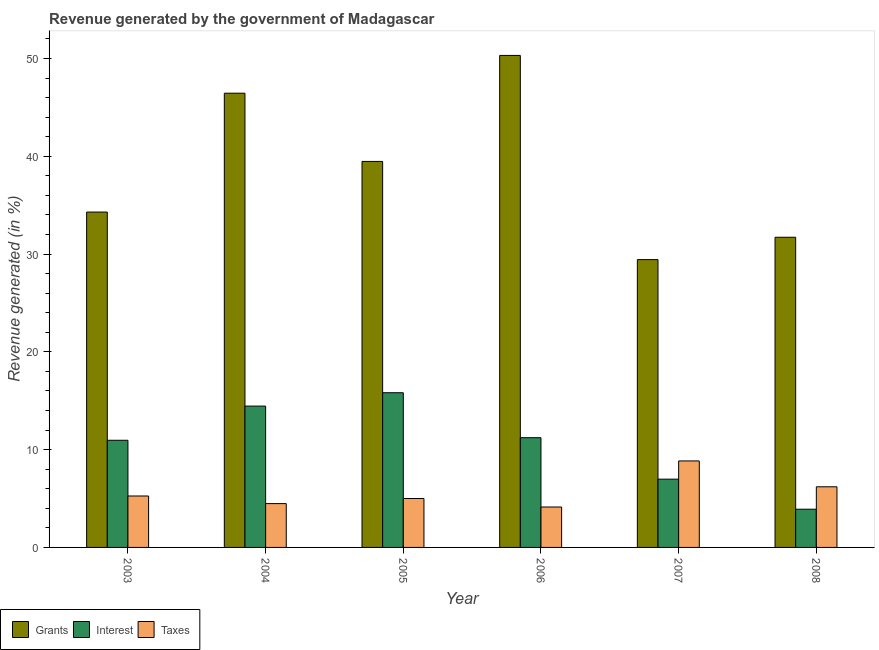How many different coloured bars are there?
Ensure brevity in your answer.  3. Are the number of bars per tick equal to the number of legend labels?
Keep it short and to the point. Yes. What is the percentage of revenue generated by taxes in 2007?
Offer a very short reply. 8.85. Across all years, what is the maximum percentage of revenue generated by grants?
Offer a terse response. 50.32. Across all years, what is the minimum percentage of revenue generated by taxes?
Your response must be concise. 4.13. In which year was the percentage of revenue generated by interest minimum?
Offer a very short reply. 2008. What is the total percentage of revenue generated by taxes in the graph?
Ensure brevity in your answer.  33.93. What is the difference between the percentage of revenue generated by taxes in 2005 and that in 2007?
Provide a short and direct response. -3.84. What is the difference between the percentage of revenue generated by grants in 2006 and the percentage of revenue generated by taxes in 2008?
Ensure brevity in your answer.  18.6. What is the average percentage of revenue generated by grants per year?
Make the answer very short. 38.62. In how many years, is the percentage of revenue generated by interest greater than 12 %?
Provide a succinct answer. 2. What is the ratio of the percentage of revenue generated by interest in 2004 to that in 2008?
Your answer should be very brief. 3.7. Is the percentage of revenue generated by interest in 2004 less than that in 2006?
Provide a short and direct response. No. Is the difference between the percentage of revenue generated by taxes in 2005 and 2007 greater than the difference between the percentage of revenue generated by grants in 2005 and 2007?
Provide a succinct answer. No. What is the difference between the highest and the second highest percentage of revenue generated by taxes?
Keep it short and to the point. 2.65. What is the difference between the highest and the lowest percentage of revenue generated by grants?
Offer a very short reply. 20.88. In how many years, is the percentage of revenue generated by grants greater than the average percentage of revenue generated by grants taken over all years?
Your answer should be compact. 3. Is the sum of the percentage of revenue generated by grants in 2003 and 2006 greater than the maximum percentage of revenue generated by taxes across all years?
Offer a terse response. Yes. What does the 2nd bar from the left in 2005 represents?
Offer a very short reply. Interest. What does the 1st bar from the right in 2008 represents?
Your answer should be very brief. Taxes. Are the values on the major ticks of Y-axis written in scientific E-notation?
Your answer should be very brief. No. Does the graph contain any zero values?
Keep it short and to the point. No. How many legend labels are there?
Provide a succinct answer. 3. What is the title of the graph?
Your response must be concise. Revenue generated by the government of Madagascar. What is the label or title of the X-axis?
Keep it short and to the point. Year. What is the label or title of the Y-axis?
Provide a succinct answer. Revenue generated (in %). What is the Revenue generated (in %) of Grants in 2003?
Give a very brief answer. 34.3. What is the Revenue generated (in %) of Interest in 2003?
Your response must be concise. 10.96. What is the Revenue generated (in %) in Taxes in 2003?
Keep it short and to the point. 5.26. What is the Revenue generated (in %) in Grants in 2004?
Your response must be concise. 46.45. What is the Revenue generated (in %) of Interest in 2004?
Offer a terse response. 14.45. What is the Revenue generated (in %) in Taxes in 2004?
Ensure brevity in your answer.  4.48. What is the Revenue generated (in %) in Grants in 2005?
Provide a succinct answer. 39.48. What is the Revenue generated (in %) in Interest in 2005?
Your response must be concise. 15.82. What is the Revenue generated (in %) in Taxes in 2005?
Make the answer very short. 5. What is the Revenue generated (in %) of Grants in 2006?
Your response must be concise. 50.32. What is the Revenue generated (in %) in Interest in 2006?
Your response must be concise. 11.22. What is the Revenue generated (in %) of Taxes in 2006?
Make the answer very short. 4.13. What is the Revenue generated (in %) in Grants in 2007?
Offer a terse response. 29.44. What is the Revenue generated (in %) in Interest in 2007?
Keep it short and to the point. 6.98. What is the Revenue generated (in %) of Taxes in 2007?
Provide a short and direct response. 8.85. What is the Revenue generated (in %) of Grants in 2008?
Your answer should be compact. 31.72. What is the Revenue generated (in %) in Interest in 2008?
Your response must be concise. 3.91. What is the Revenue generated (in %) of Taxes in 2008?
Offer a very short reply. 6.2. Across all years, what is the maximum Revenue generated (in %) in Grants?
Keep it short and to the point. 50.32. Across all years, what is the maximum Revenue generated (in %) in Interest?
Your response must be concise. 15.82. Across all years, what is the maximum Revenue generated (in %) of Taxes?
Your response must be concise. 8.85. Across all years, what is the minimum Revenue generated (in %) in Grants?
Offer a terse response. 29.44. Across all years, what is the minimum Revenue generated (in %) in Interest?
Make the answer very short. 3.91. Across all years, what is the minimum Revenue generated (in %) in Taxes?
Your response must be concise. 4.13. What is the total Revenue generated (in %) of Grants in the graph?
Offer a terse response. 231.7. What is the total Revenue generated (in %) in Interest in the graph?
Make the answer very short. 63.35. What is the total Revenue generated (in %) of Taxes in the graph?
Your response must be concise. 33.93. What is the difference between the Revenue generated (in %) of Grants in 2003 and that in 2004?
Your response must be concise. -12.16. What is the difference between the Revenue generated (in %) in Interest in 2003 and that in 2004?
Ensure brevity in your answer.  -3.5. What is the difference between the Revenue generated (in %) of Taxes in 2003 and that in 2004?
Give a very brief answer. 0.78. What is the difference between the Revenue generated (in %) of Grants in 2003 and that in 2005?
Your answer should be very brief. -5.18. What is the difference between the Revenue generated (in %) in Interest in 2003 and that in 2005?
Your answer should be very brief. -4.86. What is the difference between the Revenue generated (in %) in Taxes in 2003 and that in 2005?
Give a very brief answer. 0.26. What is the difference between the Revenue generated (in %) in Grants in 2003 and that in 2006?
Offer a very short reply. -16.02. What is the difference between the Revenue generated (in %) in Interest in 2003 and that in 2006?
Give a very brief answer. -0.26. What is the difference between the Revenue generated (in %) of Taxes in 2003 and that in 2006?
Your answer should be very brief. 1.13. What is the difference between the Revenue generated (in %) in Grants in 2003 and that in 2007?
Provide a succinct answer. 4.86. What is the difference between the Revenue generated (in %) in Interest in 2003 and that in 2007?
Keep it short and to the point. 3.98. What is the difference between the Revenue generated (in %) of Taxes in 2003 and that in 2007?
Ensure brevity in your answer.  -3.59. What is the difference between the Revenue generated (in %) of Grants in 2003 and that in 2008?
Ensure brevity in your answer.  2.58. What is the difference between the Revenue generated (in %) of Interest in 2003 and that in 2008?
Keep it short and to the point. 7.05. What is the difference between the Revenue generated (in %) in Taxes in 2003 and that in 2008?
Keep it short and to the point. -0.94. What is the difference between the Revenue generated (in %) in Grants in 2004 and that in 2005?
Keep it short and to the point. 6.98. What is the difference between the Revenue generated (in %) in Interest in 2004 and that in 2005?
Your response must be concise. -1.37. What is the difference between the Revenue generated (in %) in Taxes in 2004 and that in 2005?
Offer a very short reply. -0.52. What is the difference between the Revenue generated (in %) in Grants in 2004 and that in 2006?
Ensure brevity in your answer.  -3.86. What is the difference between the Revenue generated (in %) of Interest in 2004 and that in 2006?
Your answer should be very brief. 3.23. What is the difference between the Revenue generated (in %) in Taxes in 2004 and that in 2006?
Offer a very short reply. 0.35. What is the difference between the Revenue generated (in %) of Grants in 2004 and that in 2007?
Provide a succinct answer. 17.02. What is the difference between the Revenue generated (in %) of Interest in 2004 and that in 2007?
Your answer should be very brief. 7.47. What is the difference between the Revenue generated (in %) of Taxes in 2004 and that in 2007?
Make the answer very short. -4.36. What is the difference between the Revenue generated (in %) in Grants in 2004 and that in 2008?
Your answer should be compact. 14.73. What is the difference between the Revenue generated (in %) of Interest in 2004 and that in 2008?
Provide a succinct answer. 10.55. What is the difference between the Revenue generated (in %) of Taxes in 2004 and that in 2008?
Your answer should be compact. -1.72. What is the difference between the Revenue generated (in %) in Grants in 2005 and that in 2006?
Your response must be concise. -10.84. What is the difference between the Revenue generated (in %) in Interest in 2005 and that in 2006?
Your answer should be compact. 4.6. What is the difference between the Revenue generated (in %) of Taxes in 2005 and that in 2006?
Keep it short and to the point. 0.87. What is the difference between the Revenue generated (in %) of Grants in 2005 and that in 2007?
Make the answer very short. 10.04. What is the difference between the Revenue generated (in %) in Interest in 2005 and that in 2007?
Provide a short and direct response. 8.84. What is the difference between the Revenue generated (in %) in Taxes in 2005 and that in 2007?
Provide a short and direct response. -3.84. What is the difference between the Revenue generated (in %) in Grants in 2005 and that in 2008?
Provide a short and direct response. 7.75. What is the difference between the Revenue generated (in %) in Interest in 2005 and that in 2008?
Make the answer very short. 11.91. What is the difference between the Revenue generated (in %) of Taxes in 2005 and that in 2008?
Your answer should be very brief. -1.2. What is the difference between the Revenue generated (in %) in Grants in 2006 and that in 2007?
Offer a terse response. 20.88. What is the difference between the Revenue generated (in %) of Interest in 2006 and that in 2007?
Your answer should be compact. 4.24. What is the difference between the Revenue generated (in %) in Taxes in 2006 and that in 2007?
Your answer should be compact. -4.71. What is the difference between the Revenue generated (in %) in Grants in 2006 and that in 2008?
Give a very brief answer. 18.6. What is the difference between the Revenue generated (in %) of Interest in 2006 and that in 2008?
Your response must be concise. 7.32. What is the difference between the Revenue generated (in %) of Taxes in 2006 and that in 2008?
Provide a succinct answer. -2.07. What is the difference between the Revenue generated (in %) of Grants in 2007 and that in 2008?
Provide a short and direct response. -2.29. What is the difference between the Revenue generated (in %) of Interest in 2007 and that in 2008?
Offer a very short reply. 3.07. What is the difference between the Revenue generated (in %) of Taxes in 2007 and that in 2008?
Your response must be concise. 2.65. What is the difference between the Revenue generated (in %) in Grants in 2003 and the Revenue generated (in %) in Interest in 2004?
Make the answer very short. 19.84. What is the difference between the Revenue generated (in %) of Grants in 2003 and the Revenue generated (in %) of Taxes in 2004?
Offer a very short reply. 29.82. What is the difference between the Revenue generated (in %) of Interest in 2003 and the Revenue generated (in %) of Taxes in 2004?
Make the answer very short. 6.48. What is the difference between the Revenue generated (in %) in Grants in 2003 and the Revenue generated (in %) in Interest in 2005?
Your answer should be very brief. 18.48. What is the difference between the Revenue generated (in %) in Grants in 2003 and the Revenue generated (in %) in Taxes in 2005?
Make the answer very short. 29.3. What is the difference between the Revenue generated (in %) of Interest in 2003 and the Revenue generated (in %) of Taxes in 2005?
Ensure brevity in your answer.  5.96. What is the difference between the Revenue generated (in %) in Grants in 2003 and the Revenue generated (in %) in Interest in 2006?
Ensure brevity in your answer.  23.08. What is the difference between the Revenue generated (in %) in Grants in 2003 and the Revenue generated (in %) in Taxes in 2006?
Provide a short and direct response. 30.16. What is the difference between the Revenue generated (in %) in Interest in 2003 and the Revenue generated (in %) in Taxes in 2006?
Your answer should be very brief. 6.82. What is the difference between the Revenue generated (in %) of Grants in 2003 and the Revenue generated (in %) of Interest in 2007?
Give a very brief answer. 27.32. What is the difference between the Revenue generated (in %) of Grants in 2003 and the Revenue generated (in %) of Taxes in 2007?
Provide a short and direct response. 25.45. What is the difference between the Revenue generated (in %) of Interest in 2003 and the Revenue generated (in %) of Taxes in 2007?
Give a very brief answer. 2.11. What is the difference between the Revenue generated (in %) in Grants in 2003 and the Revenue generated (in %) in Interest in 2008?
Ensure brevity in your answer.  30.39. What is the difference between the Revenue generated (in %) of Grants in 2003 and the Revenue generated (in %) of Taxes in 2008?
Your answer should be very brief. 28.1. What is the difference between the Revenue generated (in %) of Interest in 2003 and the Revenue generated (in %) of Taxes in 2008?
Your response must be concise. 4.76. What is the difference between the Revenue generated (in %) of Grants in 2004 and the Revenue generated (in %) of Interest in 2005?
Keep it short and to the point. 30.63. What is the difference between the Revenue generated (in %) in Grants in 2004 and the Revenue generated (in %) in Taxes in 2005?
Provide a succinct answer. 41.45. What is the difference between the Revenue generated (in %) in Interest in 2004 and the Revenue generated (in %) in Taxes in 2005?
Provide a succinct answer. 9.45. What is the difference between the Revenue generated (in %) in Grants in 2004 and the Revenue generated (in %) in Interest in 2006?
Provide a succinct answer. 35.23. What is the difference between the Revenue generated (in %) of Grants in 2004 and the Revenue generated (in %) of Taxes in 2006?
Make the answer very short. 42.32. What is the difference between the Revenue generated (in %) of Interest in 2004 and the Revenue generated (in %) of Taxes in 2006?
Provide a short and direct response. 10.32. What is the difference between the Revenue generated (in %) of Grants in 2004 and the Revenue generated (in %) of Interest in 2007?
Offer a very short reply. 39.47. What is the difference between the Revenue generated (in %) of Grants in 2004 and the Revenue generated (in %) of Taxes in 2007?
Keep it short and to the point. 37.61. What is the difference between the Revenue generated (in %) of Interest in 2004 and the Revenue generated (in %) of Taxes in 2007?
Ensure brevity in your answer.  5.61. What is the difference between the Revenue generated (in %) of Grants in 2004 and the Revenue generated (in %) of Interest in 2008?
Your response must be concise. 42.55. What is the difference between the Revenue generated (in %) of Grants in 2004 and the Revenue generated (in %) of Taxes in 2008?
Your answer should be very brief. 40.25. What is the difference between the Revenue generated (in %) in Interest in 2004 and the Revenue generated (in %) in Taxes in 2008?
Your answer should be compact. 8.25. What is the difference between the Revenue generated (in %) of Grants in 2005 and the Revenue generated (in %) of Interest in 2006?
Offer a terse response. 28.25. What is the difference between the Revenue generated (in %) in Grants in 2005 and the Revenue generated (in %) in Taxes in 2006?
Offer a terse response. 35.34. What is the difference between the Revenue generated (in %) of Interest in 2005 and the Revenue generated (in %) of Taxes in 2006?
Offer a very short reply. 11.69. What is the difference between the Revenue generated (in %) of Grants in 2005 and the Revenue generated (in %) of Interest in 2007?
Ensure brevity in your answer.  32.49. What is the difference between the Revenue generated (in %) in Grants in 2005 and the Revenue generated (in %) in Taxes in 2007?
Your answer should be very brief. 30.63. What is the difference between the Revenue generated (in %) in Interest in 2005 and the Revenue generated (in %) in Taxes in 2007?
Make the answer very short. 6.97. What is the difference between the Revenue generated (in %) of Grants in 2005 and the Revenue generated (in %) of Interest in 2008?
Ensure brevity in your answer.  35.57. What is the difference between the Revenue generated (in %) in Grants in 2005 and the Revenue generated (in %) in Taxes in 2008?
Make the answer very short. 33.27. What is the difference between the Revenue generated (in %) of Interest in 2005 and the Revenue generated (in %) of Taxes in 2008?
Offer a terse response. 9.62. What is the difference between the Revenue generated (in %) in Grants in 2006 and the Revenue generated (in %) in Interest in 2007?
Your answer should be very brief. 43.33. What is the difference between the Revenue generated (in %) in Grants in 2006 and the Revenue generated (in %) in Taxes in 2007?
Make the answer very short. 41.47. What is the difference between the Revenue generated (in %) in Interest in 2006 and the Revenue generated (in %) in Taxes in 2007?
Your answer should be compact. 2.38. What is the difference between the Revenue generated (in %) in Grants in 2006 and the Revenue generated (in %) in Interest in 2008?
Provide a succinct answer. 46.41. What is the difference between the Revenue generated (in %) of Grants in 2006 and the Revenue generated (in %) of Taxes in 2008?
Your answer should be very brief. 44.12. What is the difference between the Revenue generated (in %) in Interest in 2006 and the Revenue generated (in %) in Taxes in 2008?
Your answer should be very brief. 5.02. What is the difference between the Revenue generated (in %) of Grants in 2007 and the Revenue generated (in %) of Interest in 2008?
Your answer should be compact. 25.53. What is the difference between the Revenue generated (in %) of Grants in 2007 and the Revenue generated (in %) of Taxes in 2008?
Your response must be concise. 23.24. What is the difference between the Revenue generated (in %) in Interest in 2007 and the Revenue generated (in %) in Taxes in 2008?
Your response must be concise. 0.78. What is the average Revenue generated (in %) of Grants per year?
Provide a succinct answer. 38.62. What is the average Revenue generated (in %) in Interest per year?
Offer a terse response. 10.56. What is the average Revenue generated (in %) in Taxes per year?
Offer a very short reply. 5.65. In the year 2003, what is the difference between the Revenue generated (in %) in Grants and Revenue generated (in %) in Interest?
Make the answer very short. 23.34. In the year 2003, what is the difference between the Revenue generated (in %) of Grants and Revenue generated (in %) of Taxes?
Provide a succinct answer. 29.04. In the year 2003, what is the difference between the Revenue generated (in %) in Interest and Revenue generated (in %) in Taxes?
Keep it short and to the point. 5.7. In the year 2004, what is the difference between the Revenue generated (in %) of Grants and Revenue generated (in %) of Interest?
Offer a very short reply. 32. In the year 2004, what is the difference between the Revenue generated (in %) of Grants and Revenue generated (in %) of Taxes?
Give a very brief answer. 41.97. In the year 2004, what is the difference between the Revenue generated (in %) in Interest and Revenue generated (in %) in Taxes?
Give a very brief answer. 9.97. In the year 2005, what is the difference between the Revenue generated (in %) in Grants and Revenue generated (in %) in Interest?
Give a very brief answer. 23.65. In the year 2005, what is the difference between the Revenue generated (in %) of Grants and Revenue generated (in %) of Taxes?
Make the answer very short. 34.47. In the year 2005, what is the difference between the Revenue generated (in %) of Interest and Revenue generated (in %) of Taxes?
Ensure brevity in your answer.  10.82. In the year 2006, what is the difference between the Revenue generated (in %) of Grants and Revenue generated (in %) of Interest?
Make the answer very short. 39.09. In the year 2006, what is the difference between the Revenue generated (in %) of Grants and Revenue generated (in %) of Taxes?
Provide a succinct answer. 46.18. In the year 2006, what is the difference between the Revenue generated (in %) of Interest and Revenue generated (in %) of Taxes?
Provide a short and direct response. 7.09. In the year 2007, what is the difference between the Revenue generated (in %) of Grants and Revenue generated (in %) of Interest?
Your response must be concise. 22.45. In the year 2007, what is the difference between the Revenue generated (in %) in Grants and Revenue generated (in %) in Taxes?
Provide a succinct answer. 20.59. In the year 2007, what is the difference between the Revenue generated (in %) of Interest and Revenue generated (in %) of Taxes?
Your response must be concise. -1.86. In the year 2008, what is the difference between the Revenue generated (in %) of Grants and Revenue generated (in %) of Interest?
Offer a very short reply. 27.81. In the year 2008, what is the difference between the Revenue generated (in %) of Grants and Revenue generated (in %) of Taxes?
Your answer should be compact. 25.52. In the year 2008, what is the difference between the Revenue generated (in %) of Interest and Revenue generated (in %) of Taxes?
Your response must be concise. -2.29. What is the ratio of the Revenue generated (in %) of Grants in 2003 to that in 2004?
Provide a succinct answer. 0.74. What is the ratio of the Revenue generated (in %) in Interest in 2003 to that in 2004?
Your answer should be very brief. 0.76. What is the ratio of the Revenue generated (in %) in Taxes in 2003 to that in 2004?
Your answer should be compact. 1.17. What is the ratio of the Revenue generated (in %) of Grants in 2003 to that in 2005?
Give a very brief answer. 0.87. What is the ratio of the Revenue generated (in %) in Interest in 2003 to that in 2005?
Your answer should be compact. 0.69. What is the ratio of the Revenue generated (in %) of Taxes in 2003 to that in 2005?
Provide a short and direct response. 1.05. What is the ratio of the Revenue generated (in %) of Grants in 2003 to that in 2006?
Provide a short and direct response. 0.68. What is the ratio of the Revenue generated (in %) of Interest in 2003 to that in 2006?
Your answer should be compact. 0.98. What is the ratio of the Revenue generated (in %) in Taxes in 2003 to that in 2006?
Your answer should be compact. 1.27. What is the ratio of the Revenue generated (in %) in Grants in 2003 to that in 2007?
Your response must be concise. 1.17. What is the ratio of the Revenue generated (in %) of Interest in 2003 to that in 2007?
Your answer should be very brief. 1.57. What is the ratio of the Revenue generated (in %) of Taxes in 2003 to that in 2007?
Provide a short and direct response. 0.59. What is the ratio of the Revenue generated (in %) in Grants in 2003 to that in 2008?
Provide a short and direct response. 1.08. What is the ratio of the Revenue generated (in %) in Interest in 2003 to that in 2008?
Give a very brief answer. 2.8. What is the ratio of the Revenue generated (in %) of Taxes in 2003 to that in 2008?
Offer a very short reply. 0.85. What is the ratio of the Revenue generated (in %) of Grants in 2004 to that in 2005?
Provide a short and direct response. 1.18. What is the ratio of the Revenue generated (in %) of Interest in 2004 to that in 2005?
Ensure brevity in your answer.  0.91. What is the ratio of the Revenue generated (in %) of Taxes in 2004 to that in 2005?
Your response must be concise. 0.9. What is the ratio of the Revenue generated (in %) in Grants in 2004 to that in 2006?
Your response must be concise. 0.92. What is the ratio of the Revenue generated (in %) in Interest in 2004 to that in 2006?
Make the answer very short. 1.29. What is the ratio of the Revenue generated (in %) in Taxes in 2004 to that in 2006?
Make the answer very short. 1.08. What is the ratio of the Revenue generated (in %) of Grants in 2004 to that in 2007?
Provide a short and direct response. 1.58. What is the ratio of the Revenue generated (in %) of Interest in 2004 to that in 2007?
Provide a short and direct response. 2.07. What is the ratio of the Revenue generated (in %) in Taxes in 2004 to that in 2007?
Keep it short and to the point. 0.51. What is the ratio of the Revenue generated (in %) of Grants in 2004 to that in 2008?
Provide a succinct answer. 1.46. What is the ratio of the Revenue generated (in %) in Interest in 2004 to that in 2008?
Your answer should be very brief. 3.7. What is the ratio of the Revenue generated (in %) in Taxes in 2004 to that in 2008?
Give a very brief answer. 0.72. What is the ratio of the Revenue generated (in %) in Grants in 2005 to that in 2006?
Your answer should be very brief. 0.78. What is the ratio of the Revenue generated (in %) of Interest in 2005 to that in 2006?
Provide a short and direct response. 1.41. What is the ratio of the Revenue generated (in %) in Taxes in 2005 to that in 2006?
Your response must be concise. 1.21. What is the ratio of the Revenue generated (in %) of Grants in 2005 to that in 2007?
Provide a succinct answer. 1.34. What is the ratio of the Revenue generated (in %) in Interest in 2005 to that in 2007?
Provide a short and direct response. 2.27. What is the ratio of the Revenue generated (in %) in Taxes in 2005 to that in 2007?
Your answer should be compact. 0.57. What is the ratio of the Revenue generated (in %) in Grants in 2005 to that in 2008?
Give a very brief answer. 1.24. What is the ratio of the Revenue generated (in %) of Interest in 2005 to that in 2008?
Make the answer very short. 4.05. What is the ratio of the Revenue generated (in %) of Taxes in 2005 to that in 2008?
Your response must be concise. 0.81. What is the ratio of the Revenue generated (in %) in Grants in 2006 to that in 2007?
Ensure brevity in your answer.  1.71. What is the ratio of the Revenue generated (in %) in Interest in 2006 to that in 2007?
Make the answer very short. 1.61. What is the ratio of the Revenue generated (in %) of Taxes in 2006 to that in 2007?
Provide a short and direct response. 0.47. What is the ratio of the Revenue generated (in %) in Grants in 2006 to that in 2008?
Provide a short and direct response. 1.59. What is the ratio of the Revenue generated (in %) of Interest in 2006 to that in 2008?
Make the answer very short. 2.87. What is the ratio of the Revenue generated (in %) in Taxes in 2006 to that in 2008?
Offer a very short reply. 0.67. What is the ratio of the Revenue generated (in %) in Grants in 2007 to that in 2008?
Give a very brief answer. 0.93. What is the ratio of the Revenue generated (in %) in Interest in 2007 to that in 2008?
Provide a short and direct response. 1.79. What is the ratio of the Revenue generated (in %) of Taxes in 2007 to that in 2008?
Your answer should be compact. 1.43. What is the difference between the highest and the second highest Revenue generated (in %) of Grants?
Offer a terse response. 3.86. What is the difference between the highest and the second highest Revenue generated (in %) of Interest?
Provide a succinct answer. 1.37. What is the difference between the highest and the second highest Revenue generated (in %) in Taxes?
Keep it short and to the point. 2.65. What is the difference between the highest and the lowest Revenue generated (in %) of Grants?
Ensure brevity in your answer.  20.88. What is the difference between the highest and the lowest Revenue generated (in %) in Interest?
Offer a very short reply. 11.91. What is the difference between the highest and the lowest Revenue generated (in %) of Taxes?
Offer a very short reply. 4.71. 